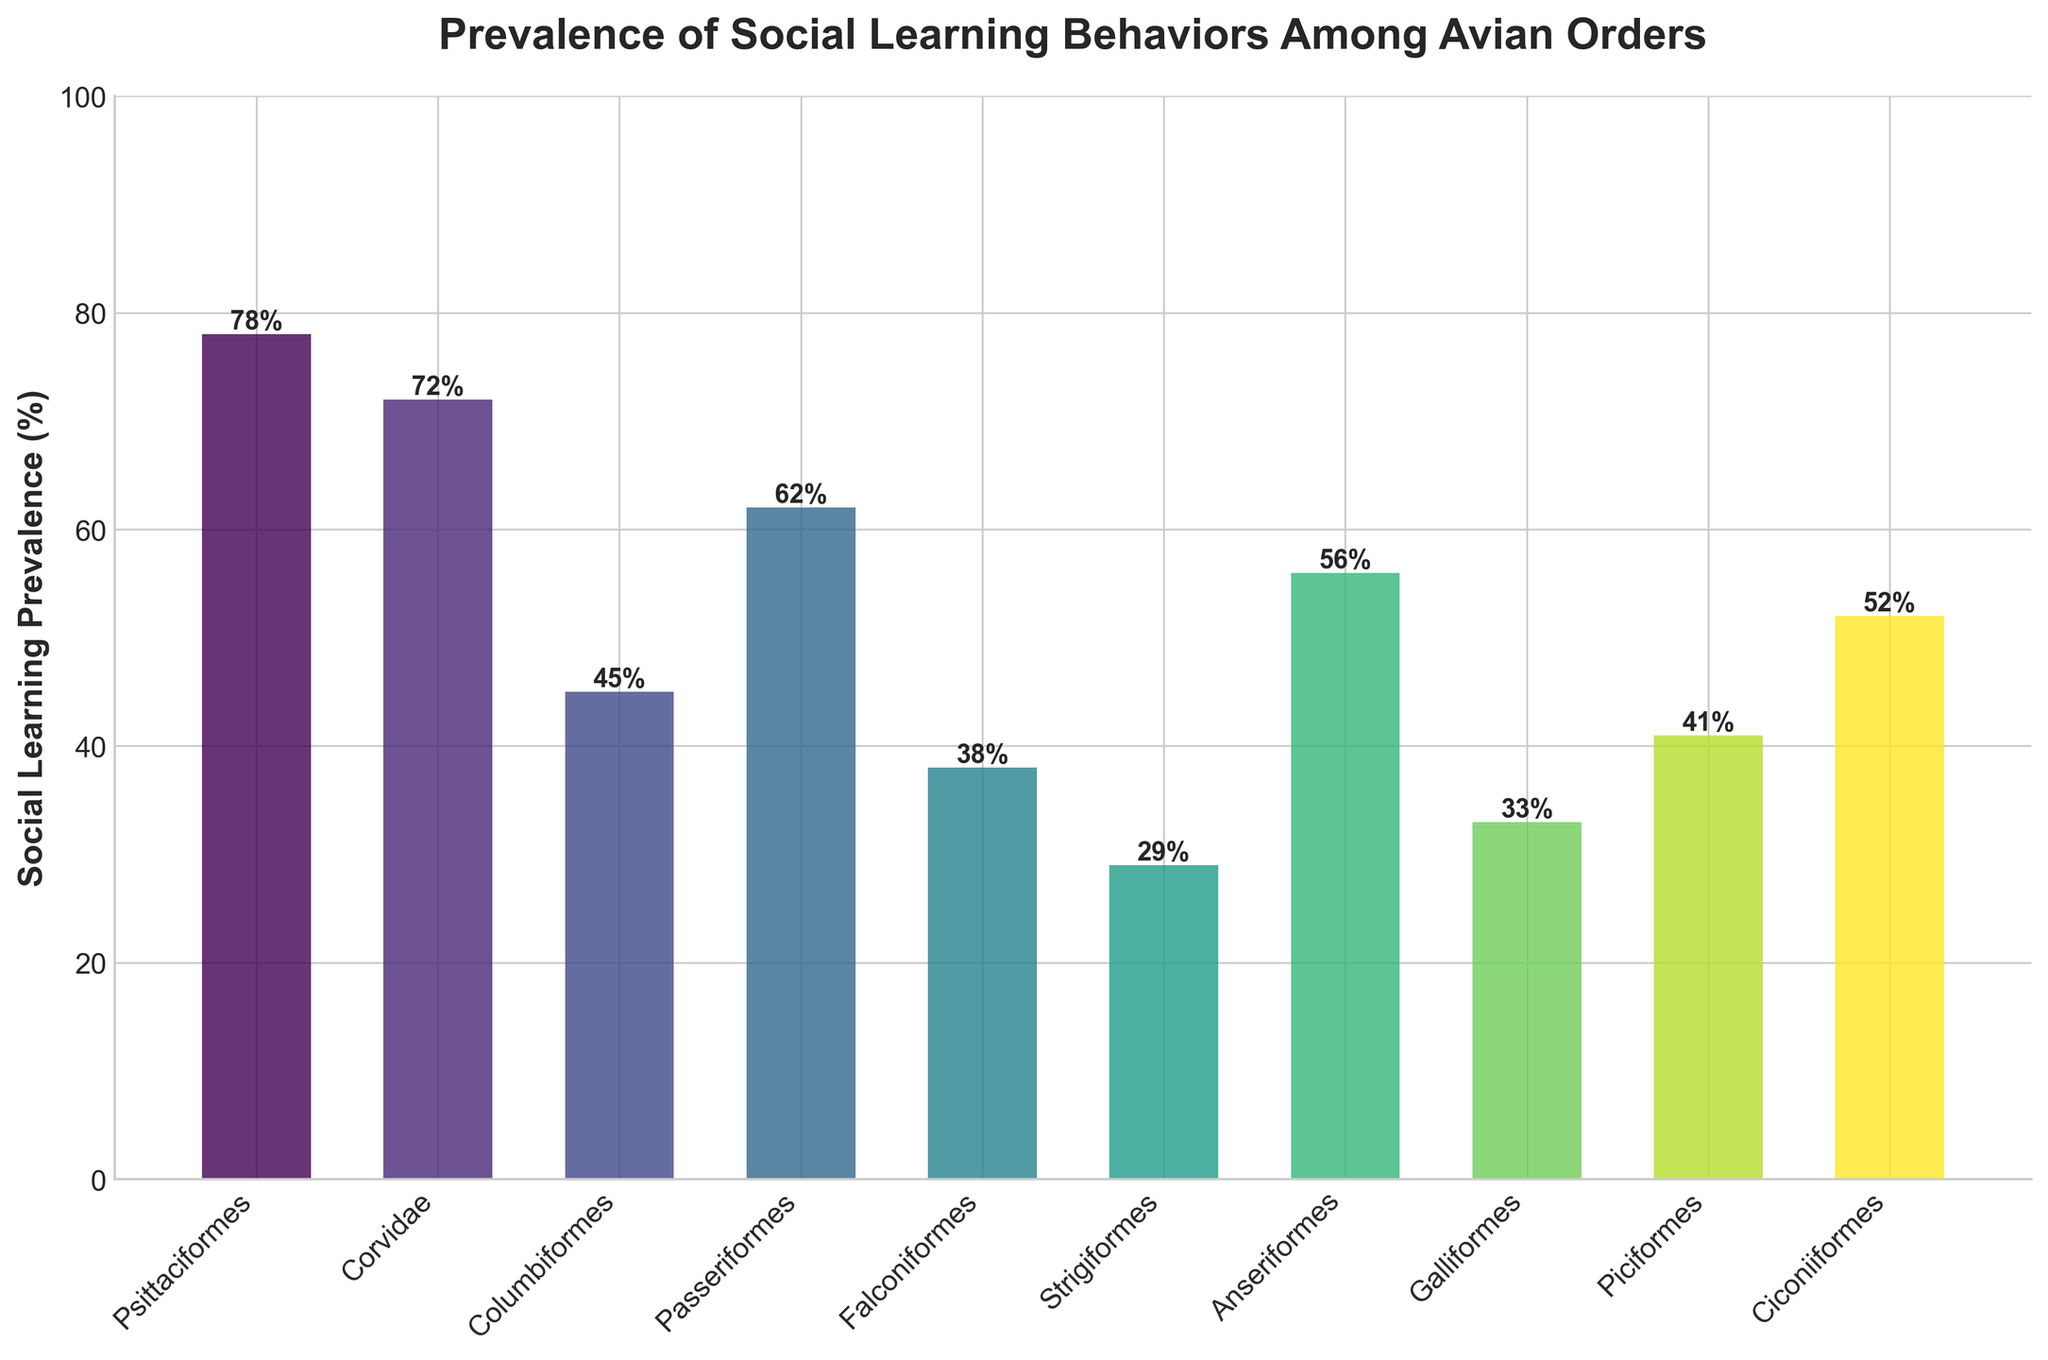Which avian order has the highest prevalence of social learning behaviors? The highest bar represents the order with the highest social learning prevalence, which is Psittaciformes at 78%.
Answer: Psittaciformes Which avian order has the lowest prevalence of social learning behaviors? The lowest bar represents the order with the lowest social learning prevalence, which is Strigiformes at 29%.
Answer: Strigiformes What is the difference in social learning prevalence between Corvidae and Galliformes? Corvidae has a prevalence of 72%, and Galliformes has a prevalence of 33%. The difference is 72% - 33% = 39%.
Answer: 39% Which orders have social learning prevalence greater than 50% but less than 70%? By examining the bars, the orders with prevalence between 50% and 70% are Passeriformes (62%), Anseriformes (56%), and Ciconiiformes (52%).
Answer: Passeriformes, Anseriformes, Ciconiiformes What is the average social learning prevalence among all the listed avian orders? Sum the social learning prevalences and divide by the number of orders: (78 + 72 + 45 + 62 + 38 + 29 + 56 + 33 + 41 + 52) / 10 = 50.6%.
Answer: 50.6% Which avian orders have a social learning prevalence less than 40%? The bars representing orders with prevalence less than 40% are Falconiformes (38%) and Strigiformes (29%).
Answer: Falconiformes, Strigiformes What is the combined social learning prevalence of the three orders with the highest prevalence? The three highest prevalences are Psittaciformes (78%), Corvidae (72%), and Passeriformes (62%). Their combined prevalence is 78% + 72% + 62% = 212%.
Answer: 212% Is the social learning prevalence of Piciformes higher or lower than the average prevalence? The average prevalence is 50.6%. Piciformes has a prevalence of 41%, which is less than the average.
Answer: Lower What is the median social learning prevalence among all the listed avian orders? First, arrange the prevalences in ascending order: 29, 33, 38, 41, 45, 52, 56, 62, 72, 78. The median is the average of the 5th and 6th values: (45 + 52)/2 = 48.5%.
Answer: 48.5% Which avian order has a social learning prevalence closest to 50%? By examining the bars and their labeled values, Ciconiiformes has a social learning prevalence of 52%, which is closest to 50%.
Answer: Ciconiiformes 